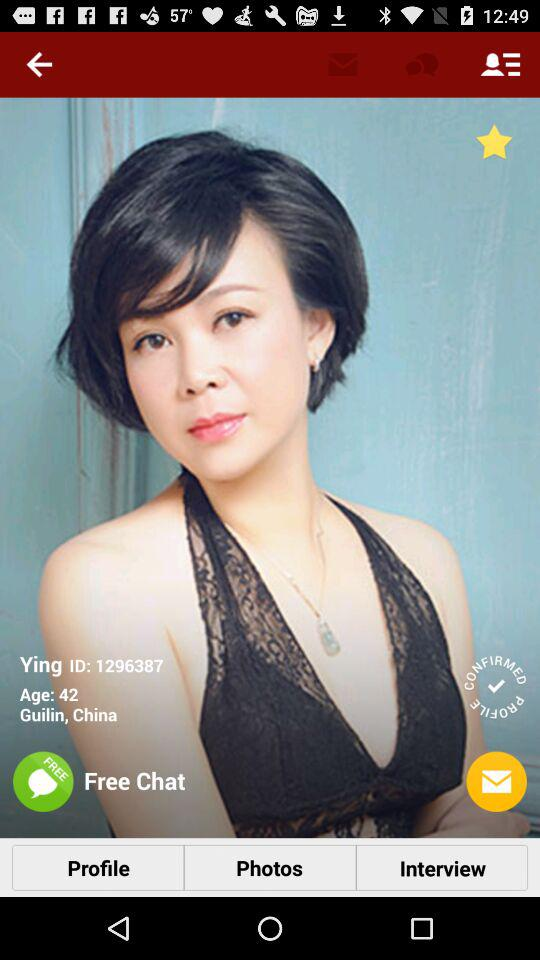In what country and city does Ying live? Ying lives in Guilin, China. 